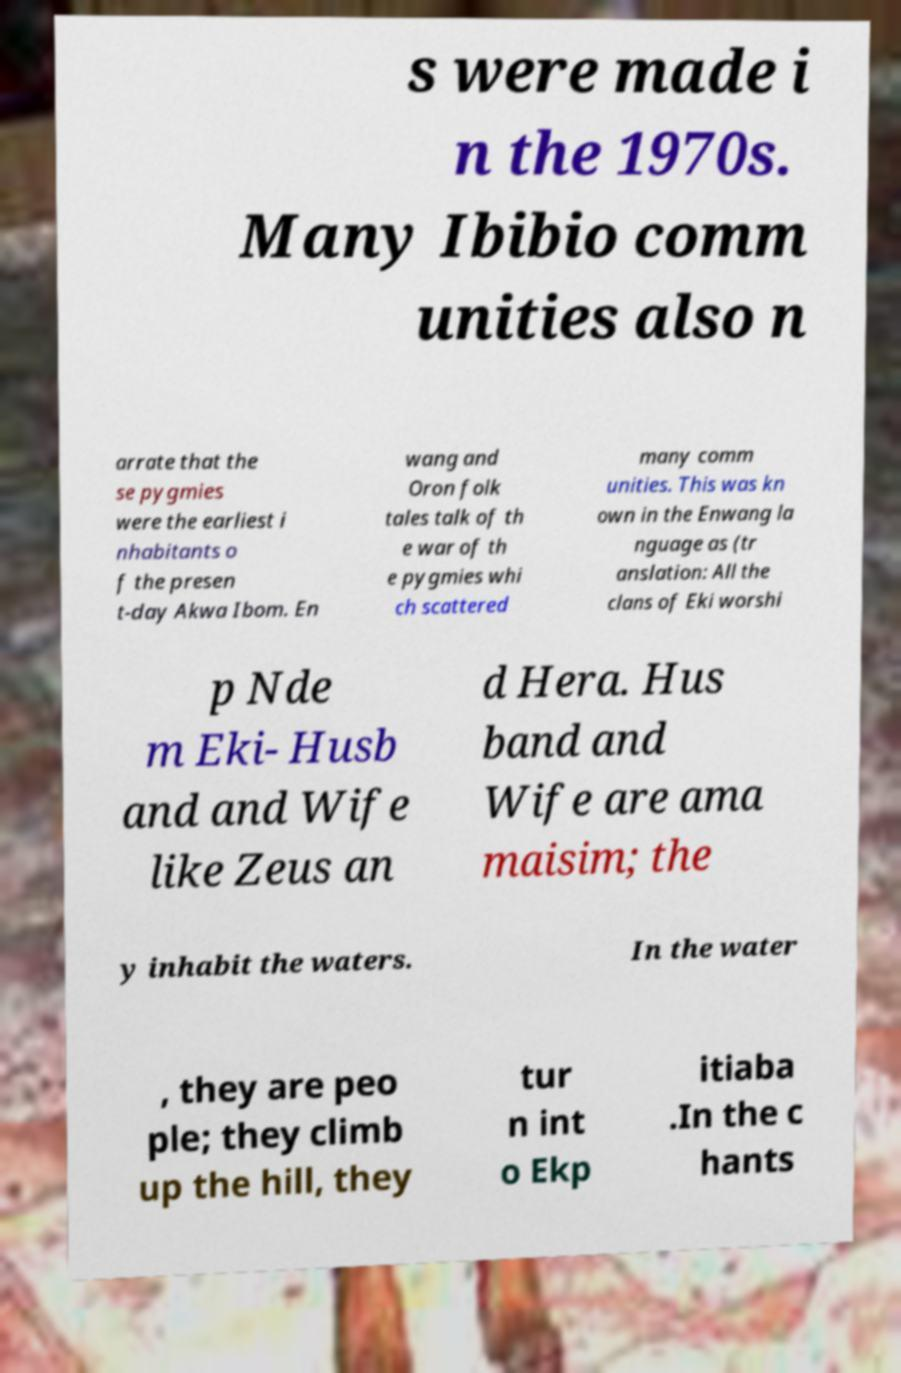Can you read and provide the text displayed in the image?This photo seems to have some interesting text. Can you extract and type it out for me? s were made i n the 1970s. Many Ibibio comm unities also n arrate that the se pygmies were the earliest i nhabitants o f the presen t-day Akwa Ibom. En wang and Oron folk tales talk of th e war of th e pygmies whi ch scattered many comm unities. This was kn own in the Enwang la nguage as (tr anslation: All the clans of Eki worshi p Nde m Eki- Husb and and Wife like Zeus an d Hera. Hus band and Wife are ama maisim; the y inhabit the waters. In the water , they are peo ple; they climb up the hill, they tur n int o Ekp itiaba .In the c hants 